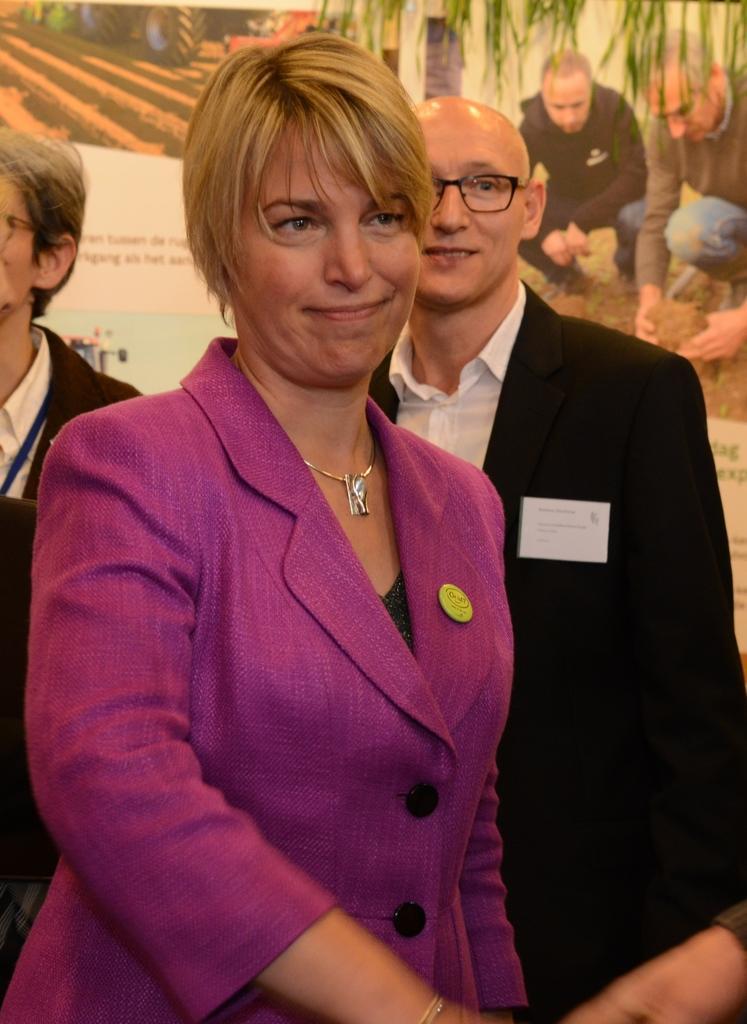Describe this image in one or two sentences. In the middle of this image, there is a woman in a pink color suit, smiling. On the right side, there is a hand of a person. In the background, there are two persons in suits, standing and there is a banner. 